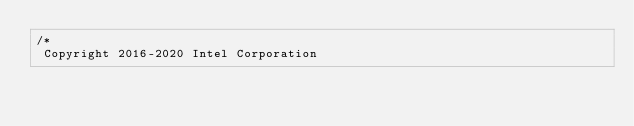<code> <loc_0><loc_0><loc_500><loc_500><_C++_>/*
 Copyright 2016-2020 Intel Corporation
 </code> 